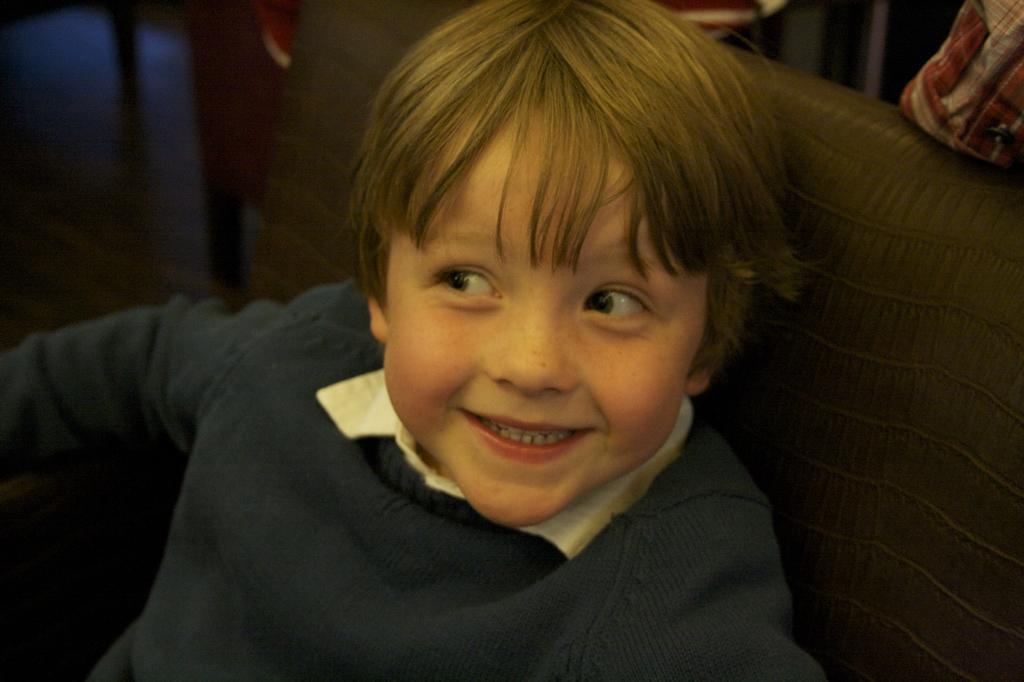Could you give a brief overview of what you see in this image? In this image we can see a person sitting on the chair. There are few objects at the right side of the image. There are few chairs at the left side of the image. 